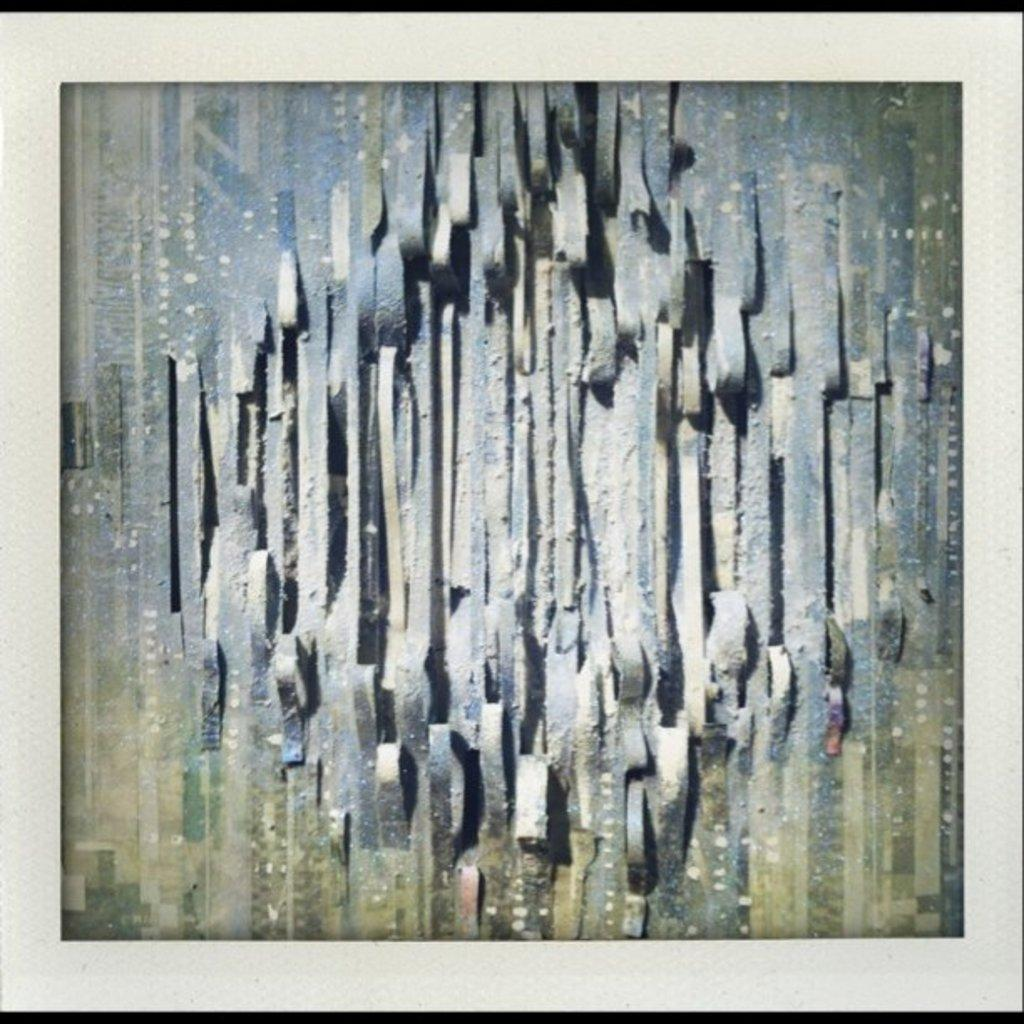What is the main subject of the image? The main subject of the image is an art piece. How is the art piece displayed in the image? The art piece is placed in a photo frame. What type of curve can be seen in the art piece? There is no curve mentioned or visible in the image, as it only features an art piece placed in a photo frame. 